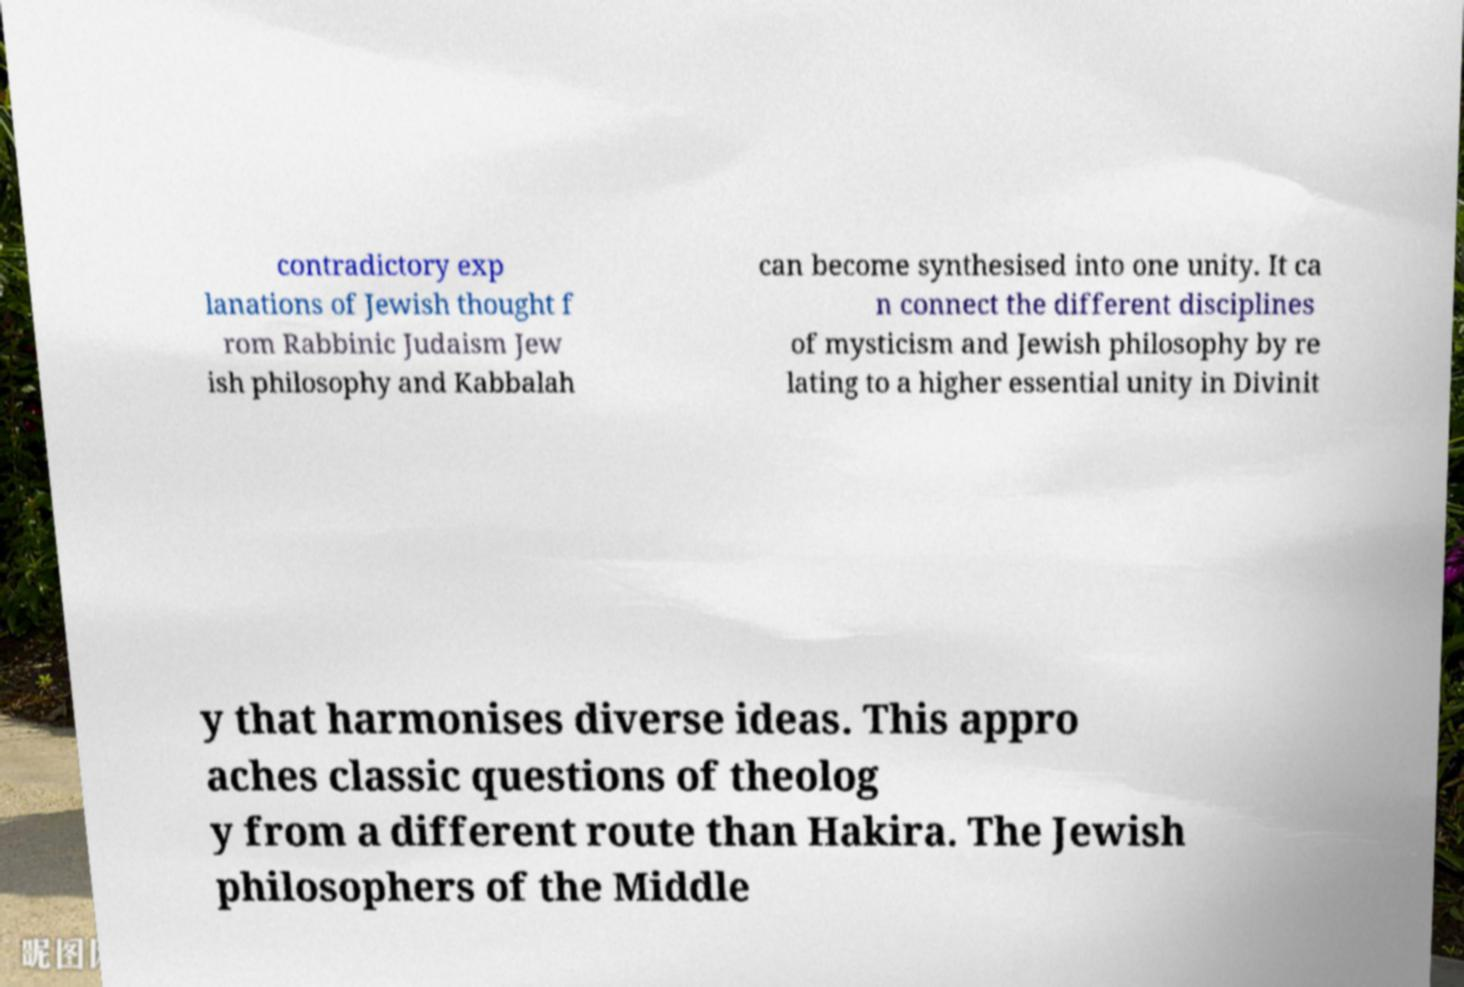Could you assist in decoding the text presented in this image and type it out clearly? contradictory exp lanations of Jewish thought f rom Rabbinic Judaism Jew ish philosophy and Kabbalah can become synthesised into one unity. It ca n connect the different disciplines of mysticism and Jewish philosophy by re lating to a higher essential unity in Divinit y that harmonises diverse ideas. This appro aches classic questions of theolog y from a different route than Hakira. The Jewish philosophers of the Middle 